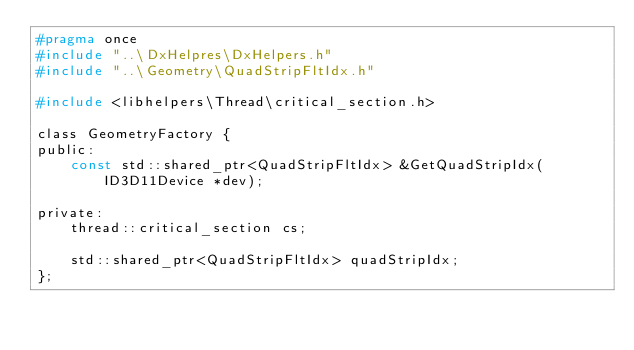Convert code to text. <code><loc_0><loc_0><loc_500><loc_500><_C_>#pragma once
#include "..\DxHelpres\DxHelpers.h"
#include "..\Geometry\QuadStripFltIdx.h"

#include <libhelpers\Thread\critical_section.h>

class GeometryFactory {
public:
	const std::shared_ptr<QuadStripFltIdx> &GetQuadStripIdx(ID3D11Device *dev);

private:
	thread::critical_section cs;

	std::shared_ptr<QuadStripFltIdx> quadStripIdx;
};</code> 